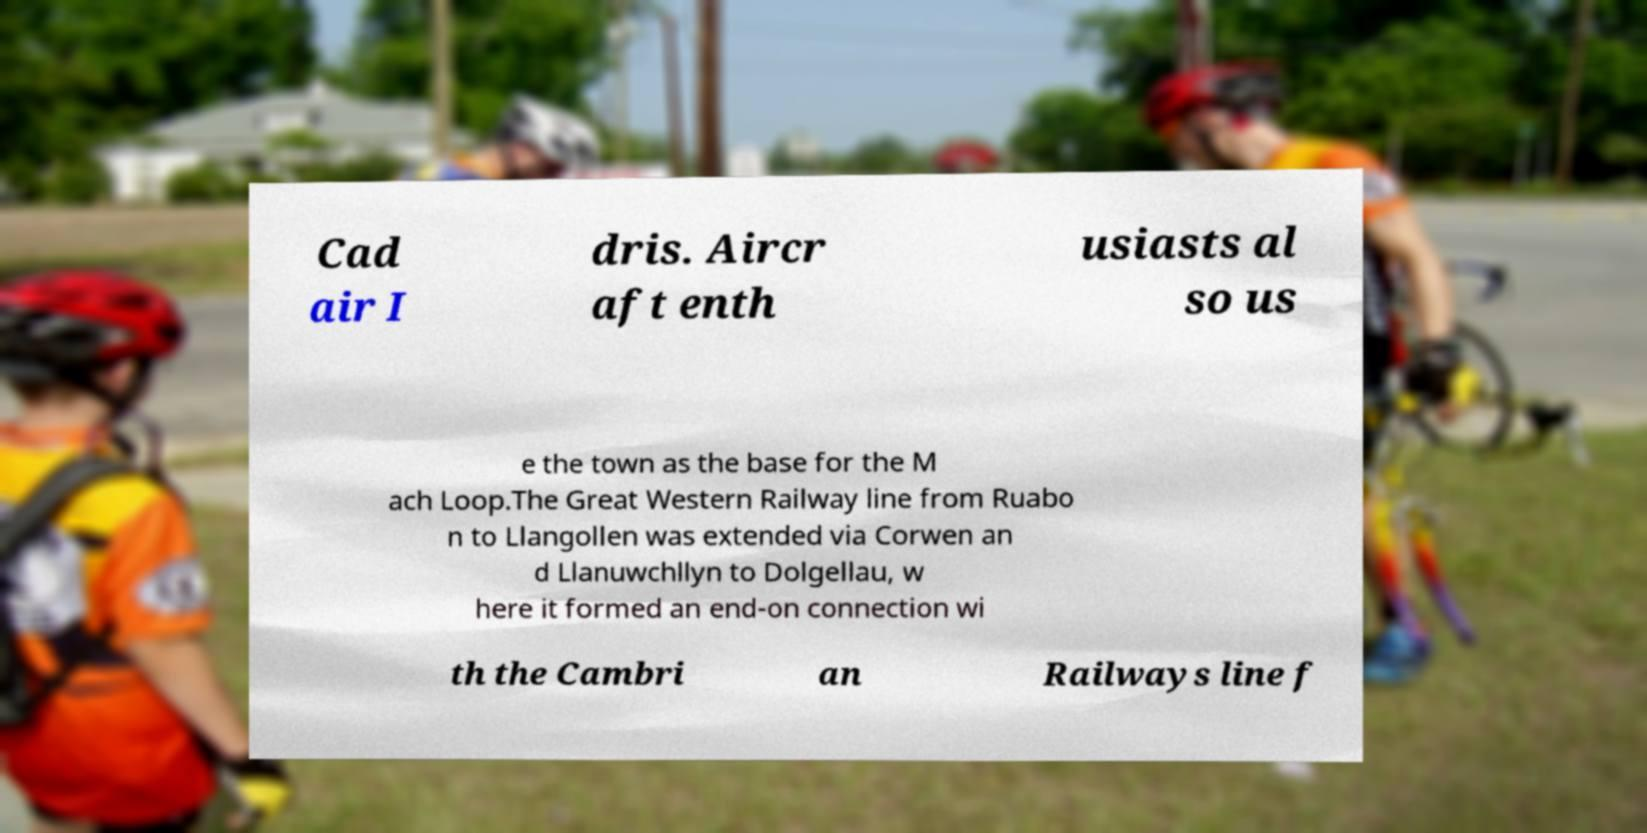Please identify and transcribe the text found in this image. Cad air I dris. Aircr aft enth usiasts al so us e the town as the base for the M ach Loop.The Great Western Railway line from Ruabo n to Llangollen was extended via Corwen an d Llanuwchllyn to Dolgellau, w here it formed an end-on connection wi th the Cambri an Railways line f 